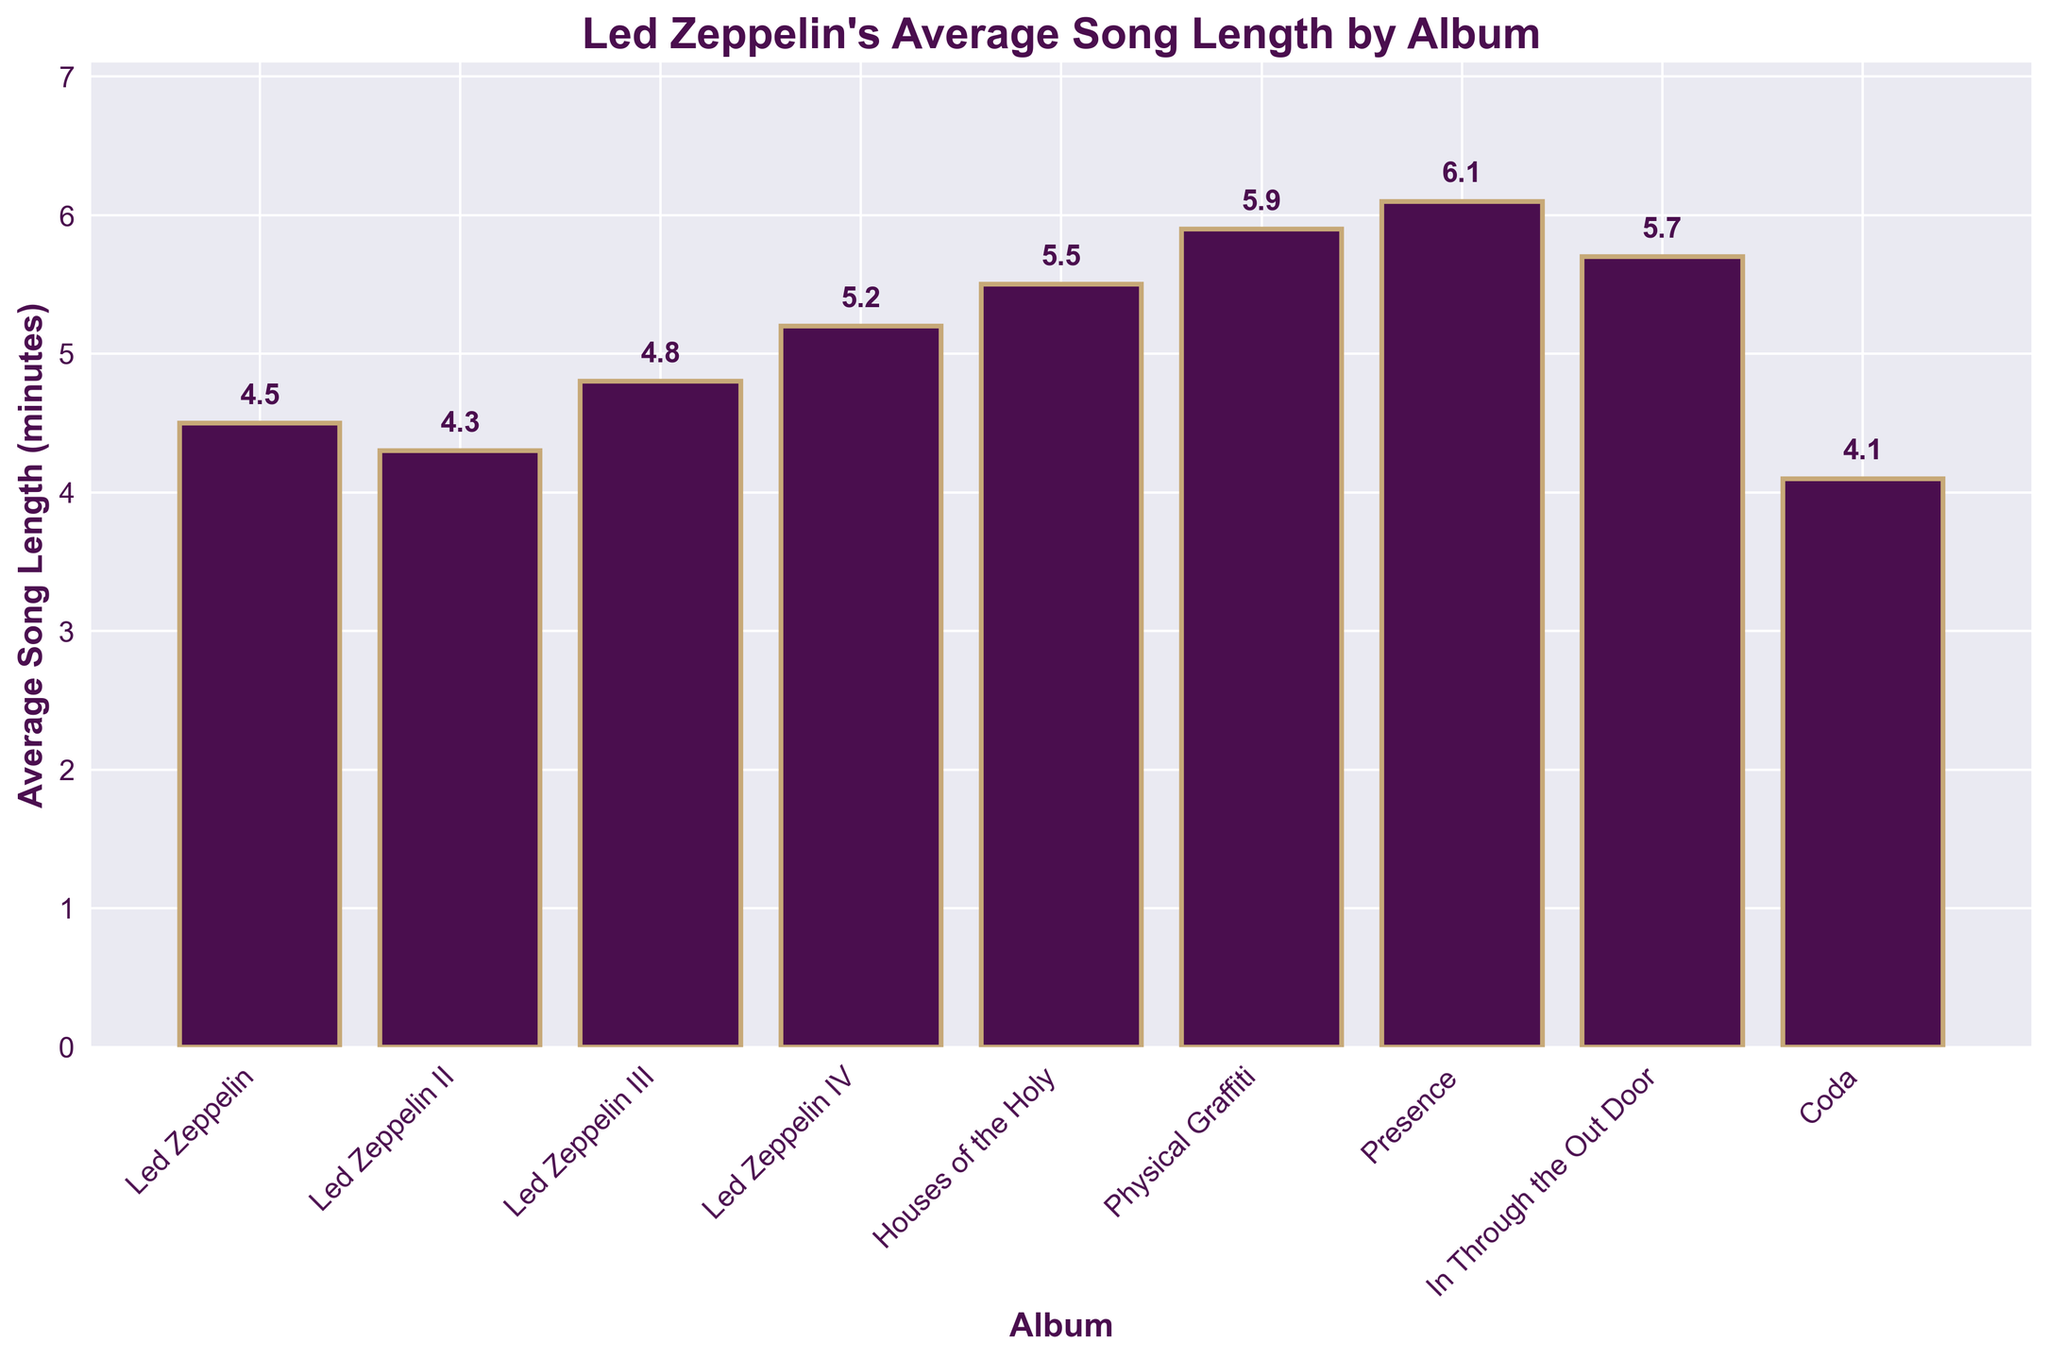Which album has the longest average song length? To find the album with the longest average song length, look at the height of the bars and the labels on the x-axis. The tallest bar corresponds to the album "Presence" with an average song length of 6.1 minutes.
Answer: Presence Which album has the shortest average song length? To determine the album with the shortest average song length, look at the shortest bar and its corresponding label. The shortest bar corresponds to the album "Coda" with an average song length of 4.1 minutes.
Answer: Coda What is the difference in average song length between "Houses of the Holy" and "In Through the Out Door"? Subtract the average song length of "In Through the Out Door" from that of "Houses of the Holy" (5.5 - 5.7). The difference is 0.2 minutes.
Answer: -0.2 Which albums have an average song length greater than 5 minutes? Identify bars with heights greater than 5 minutes and look at their labels. These albums are "Led Zeppelin IV," "Houses of the Holy," "Physical Graffiti," "Presence," and "In Through the Out Door."
Answer: Led Zeppelin IV, Houses of the Holy, Physical Graffiti, Presence, In Through the Out Door What is the combined average song length of "Led Zeppelin" and "Led Zeppelin II"? Add the average song lengths of "Led Zeppelin" and "Led Zeppelin II" (4.5 + 4.3). The combined average song length is 8.8 minutes.
Answer: 8.8 By how much does the average song length increase from "Led Zeppelin III" to "Physical Graffiti"? Subtract the average song length of "Led Zeppelin III" from that of "Physical Graffiti" (5.9 - 4.8). The increase is 1.1 minutes.
Answer: 1.1 What is the color used for the bars representing average song lengths? Observe the color of the bars in the figure, which is a shade of purple.
Answer: Purple Is the average song length of "Coda" shorter than that of "Led Zeppelin II"? Compare the bars representing "Coda" and "Led Zeppelin II". "Coda" has an average song length of 4.1 minutes, which is shorter than "Led Zeppelin II" at 4.3 minutes.
Answer: Yes Which album comes right after "Houses of the Holy" in terms of increasing average song length? Look at the order of bars by height. After "Houses of the Holy" (5.5), the next album in terms of increasing length is "In Through the Out Door" with 5.7 minutes.
Answer: In Through the Out Door 